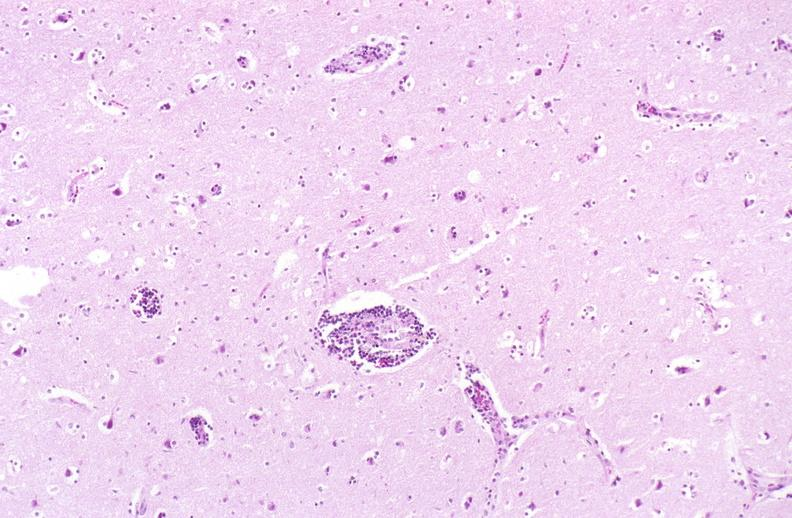what does this image show?
Answer the question using a single word or phrase. Brain 